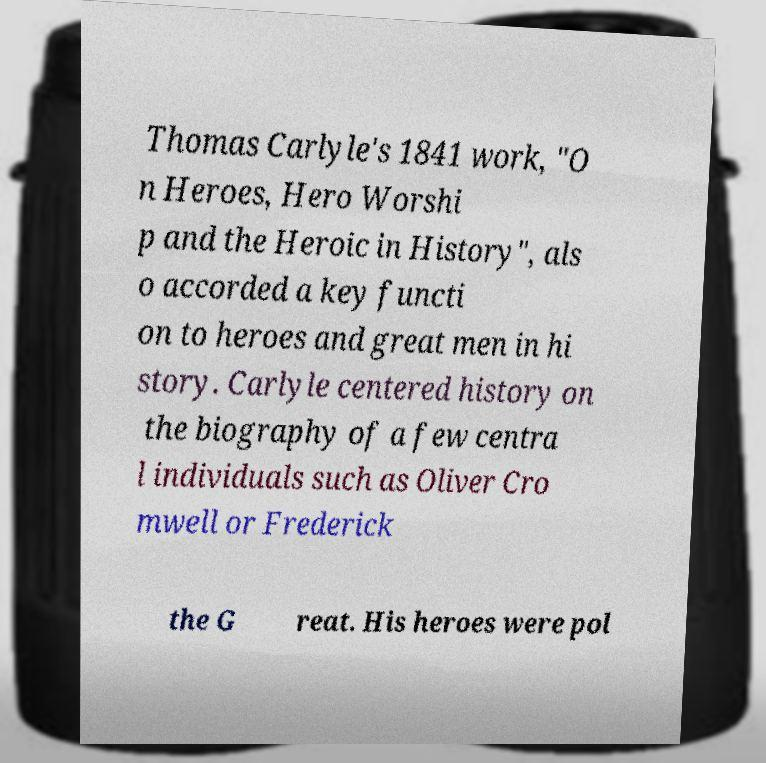Can you accurately transcribe the text from the provided image for me? Thomas Carlyle's 1841 work, "O n Heroes, Hero Worshi p and the Heroic in History", als o accorded a key functi on to heroes and great men in hi story. Carlyle centered history on the biography of a few centra l individuals such as Oliver Cro mwell or Frederick the G reat. His heroes were pol 